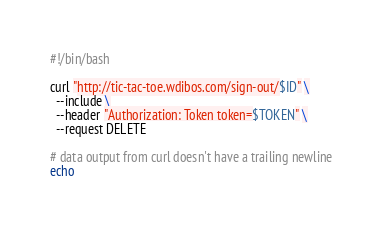Convert code to text. <code><loc_0><loc_0><loc_500><loc_500><_Bash_>#!/bin/bash

curl "http://tic-tac-toe.wdibos.com/sign-out/$ID" \
  --include \
  --header "Authorization: Token token=$TOKEN" \
  --request DELETE

# data output from curl doesn't have a trailing newline
echo
</code> 